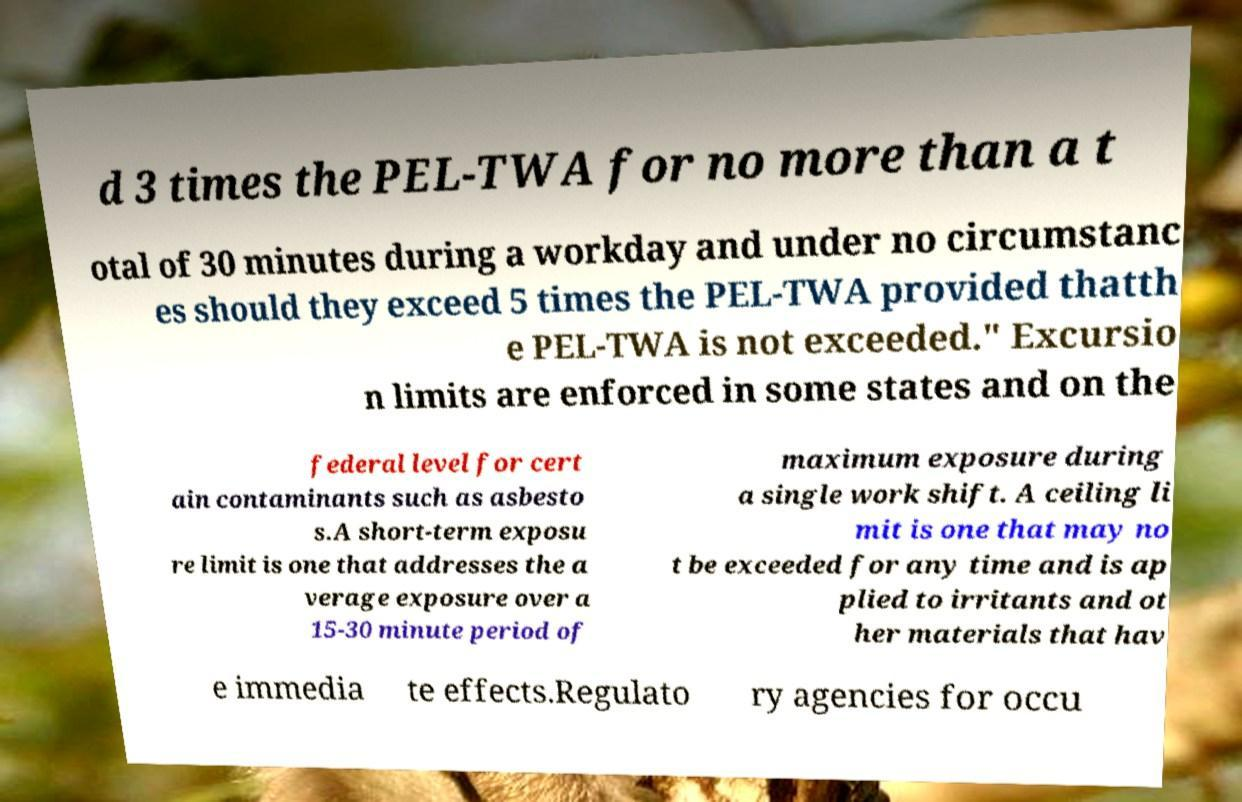There's text embedded in this image that I need extracted. Can you transcribe it verbatim? d 3 times the PEL-TWA for no more than a t otal of 30 minutes during a workday and under no circumstanc es should they exceed 5 times the PEL-TWA provided thatth e PEL-TWA is not exceeded." Excursio n limits are enforced in some states and on the federal level for cert ain contaminants such as asbesto s.A short-term exposu re limit is one that addresses the a verage exposure over a 15-30 minute period of maximum exposure during a single work shift. A ceiling li mit is one that may no t be exceeded for any time and is ap plied to irritants and ot her materials that hav e immedia te effects.Regulato ry agencies for occu 